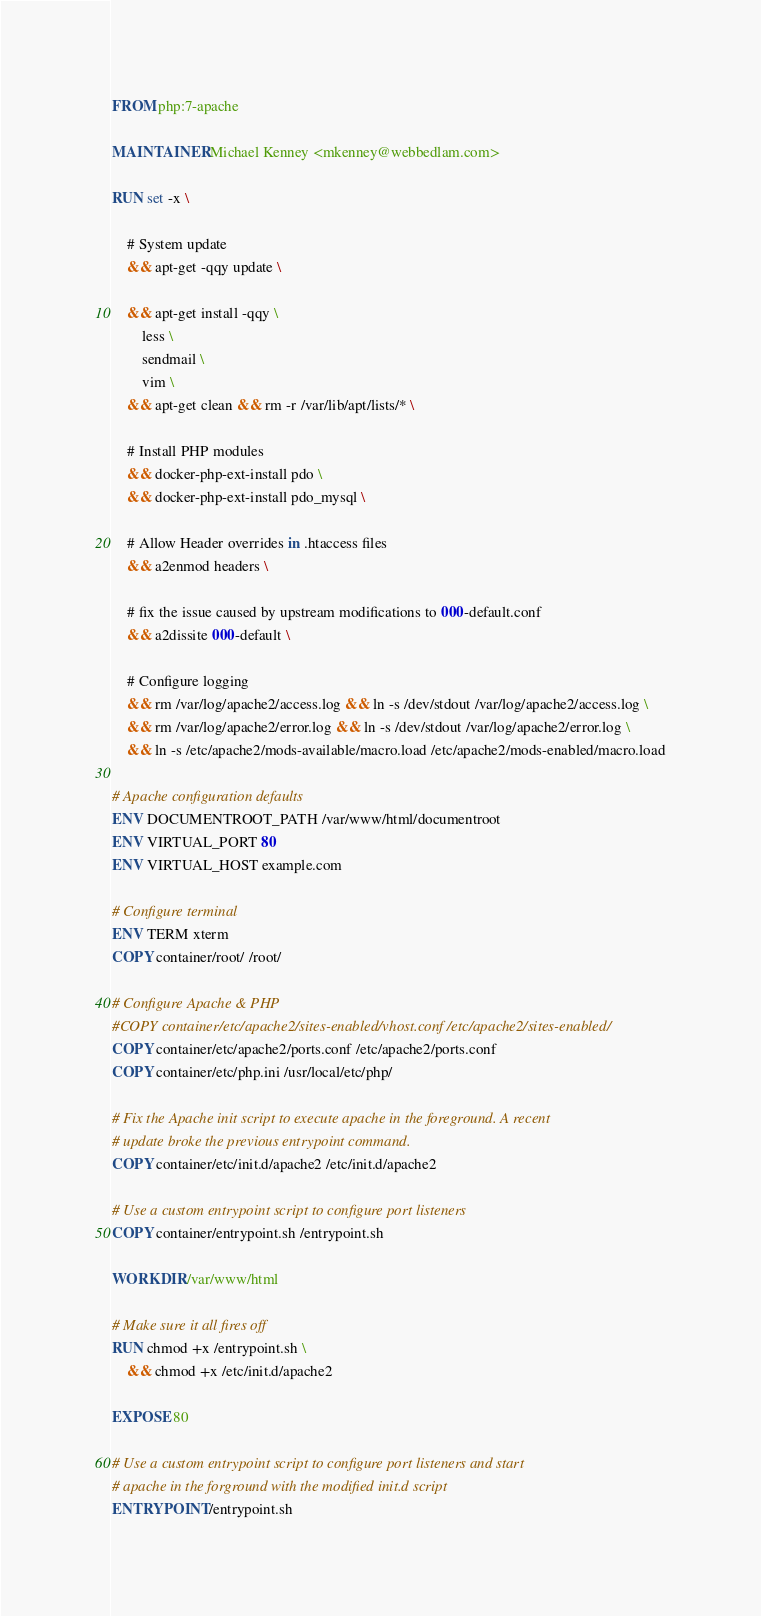<code> <loc_0><loc_0><loc_500><loc_500><_Dockerfile_>FROM php:7-apache

MAINTAINER Michael Kenney <mkenney@webbedlam.com>

RUN set -x \

    # System update
    && apt-get -qqy update \

    && apt-get install -qqy \
        less \
        sendmail \
        vim \
    && apt-get clean && rm -r /var/lib/apt/lists/* \

    # Install PHP modules
    && docker-php-ext-install pdo \
    && docker-php-ext-install pdo_mysql \

    # Allow Header overrides in .htaccess files
    && a2enmod headers \

    # fix the issue caused by upstream modifications to 000-default.conf
    && a2dissite 000-default \

    # Configure logging
    && rm /var/log/apache2/access.log && ln -s /dev/stdout /var/log/apache2/access.log \
    && rm /var/log/apache2/error.log && ln -s /dev/stdout /var/log/apache2/error.log \
    && ln -s /etc/apache2/mods-available/macro.load /etc/apache2/mods-enabled/macro.load

# Apache configuration defaults
ENV DOCUMENTROOT_PATH /var/www/html/documentroot
ENV VIRTUAL_PORT 80
ENV VIRTUAL_HOST example.com

# Configure terminal
ENV TERM xterm
COPY container/root/ /root/

# Configure Apache & PHP
#COPY container/etc/apache2/sites-enabled/vhost.conf /etc/apache2/sites-enabled/
COPY container/etc/apache2/ports.conf /etc/apache2/ports.conf
COPY container/etc/php.ini /usr/local/etc/php/

# Fix the Apache init script to execute apache in the foreground. A recent
# update broke the previous entrypoint command.
COPY container/etc/init.d/apache2 /etc/init.d/apache2

# Use a custom entrypoint script to configure port listeners
COPY container/entrypoint.sh /entrypoint.sh

WORKDIR /var/www/html

# Make sure it all fires off
RUN chmod +x /entrypoint.sh \
    && chmod +x /etc/init.d/apache2

EXPOSE 80

# Use a custom entrypoint script to configure port listeners and start
# apache in the forground with the modified init.d script
ENTRYPOINT /entrypoint.sh

</code> 